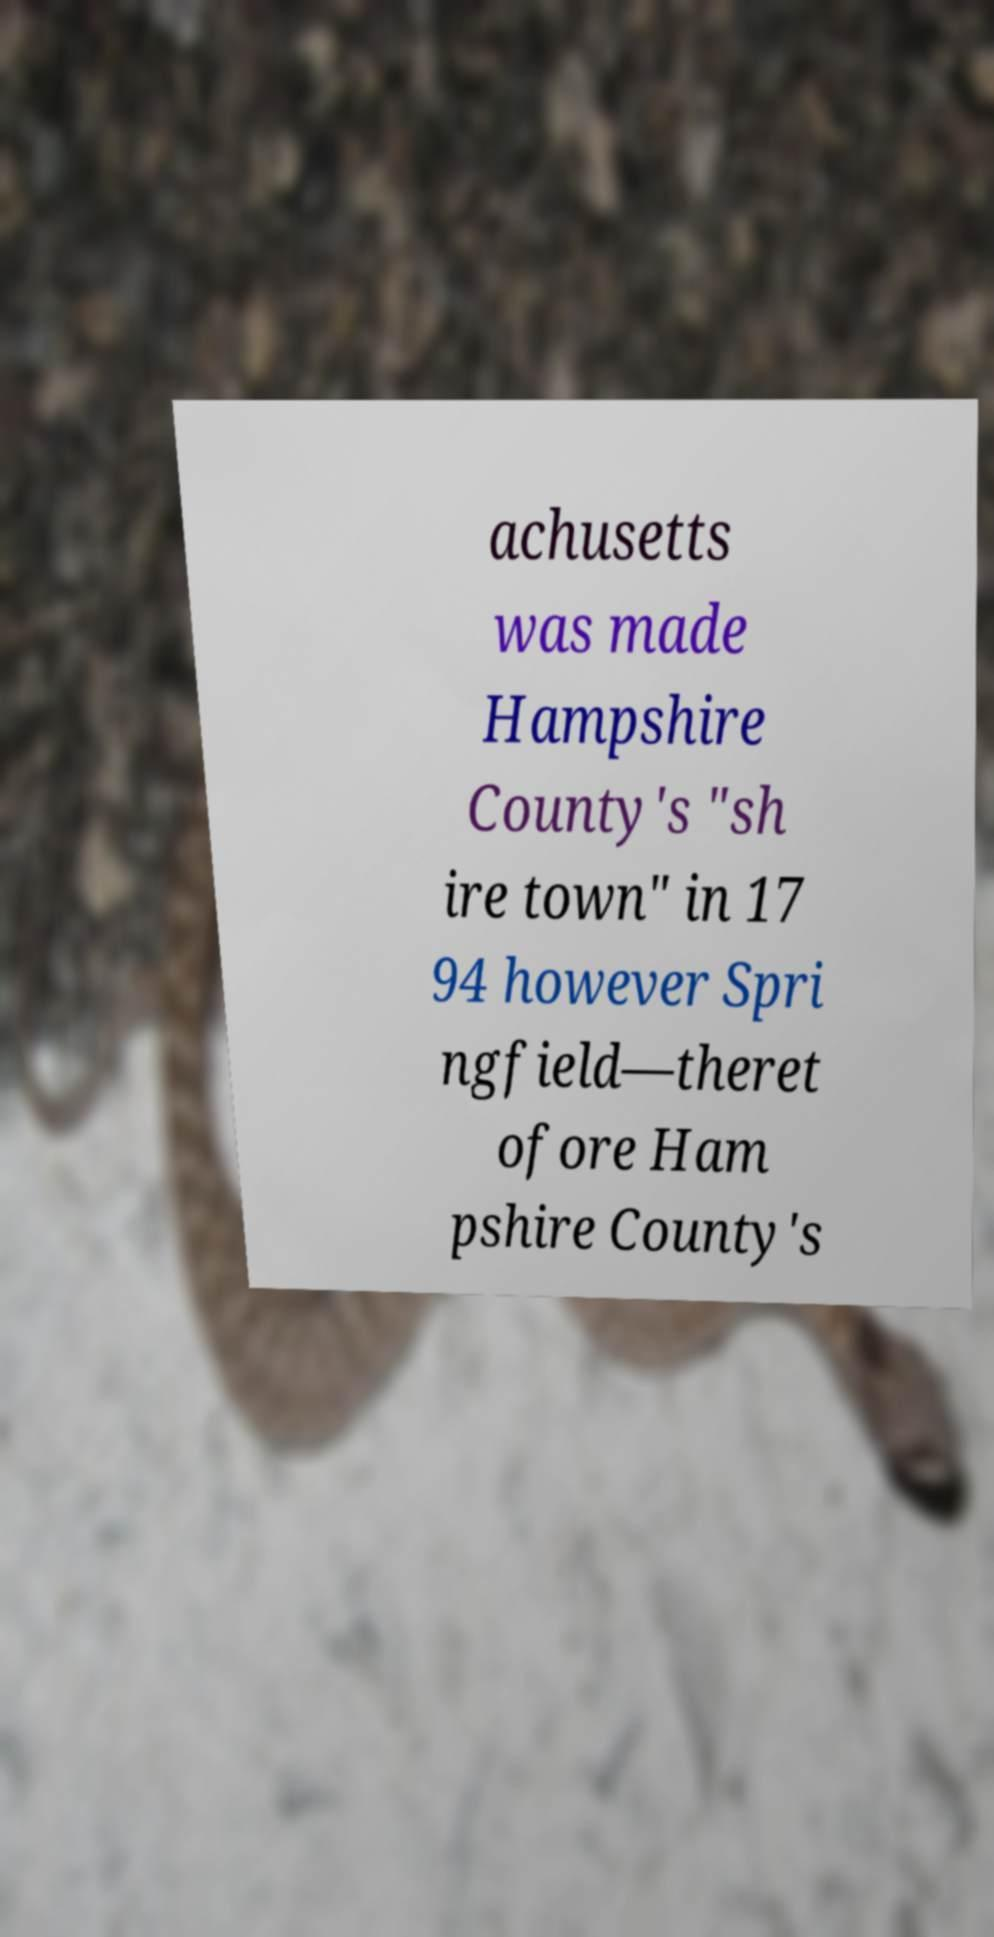Can you accurately transcribe the text from the provided image for me? achusetts was made Hampshire County's "sh ire town" in 17 94 however Spri ngfield—theret ofore Ham pshire County's 